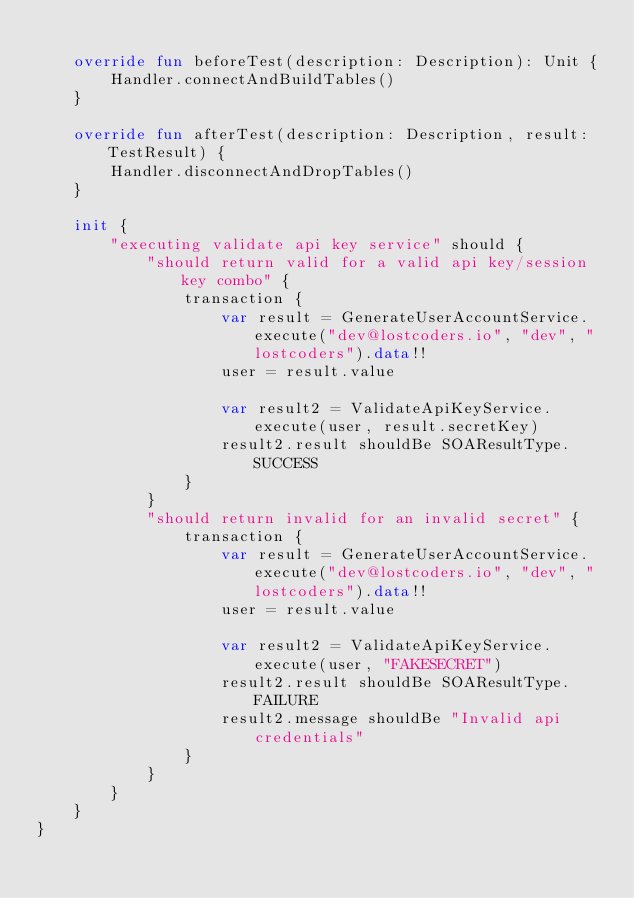Convert code to text. <code><loc_0><loc_0><loc_500><loc_500><_Kotlin_>
    override fun beforeTest(description: Description): Unit {
        Handler.connectAndBuildTables()
    }

    override fun afterTest(description: Description, result: TestResult) {
        Handler.disconnectAndDropTables()
    }

    init {
        "executing validate api key service" should {
            "should return valid for a valid api key/session key combo" {
                transaction {
                    var result = GenerateUserAccountService.execute("dev@lostcoders.io", "dev", "lostcoders").data!!
                    user = result.value

                    var result2 = ValidateApiKeyService.execute(user, result.secretKey)
                    result2.result shouldBe SOAResultType.SUCCESS
                }
            }
            "should return invalid for an invalid secret" {
                transaction {
                    var result = GenerateUserAccountService.execute("dev@lostcoders.io", "dev", "lostcoders").data!!
                    user = result.value

                    var result2 = ValidateApiKeyService.execute(user, "FAKESECRET")
                    result2.result shouldBe SOAResultType.FAILURE
                    result2.message shouldBe "Invalid api credentials"
                }
            }
        }
    }
}</code> 